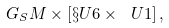Convert formula to latex. <formula><loc_0><loc_0><loc_500><loc_500>G _ { S } M \times [ \S U 6 \times \ U 1 ] \, ,</formula> 